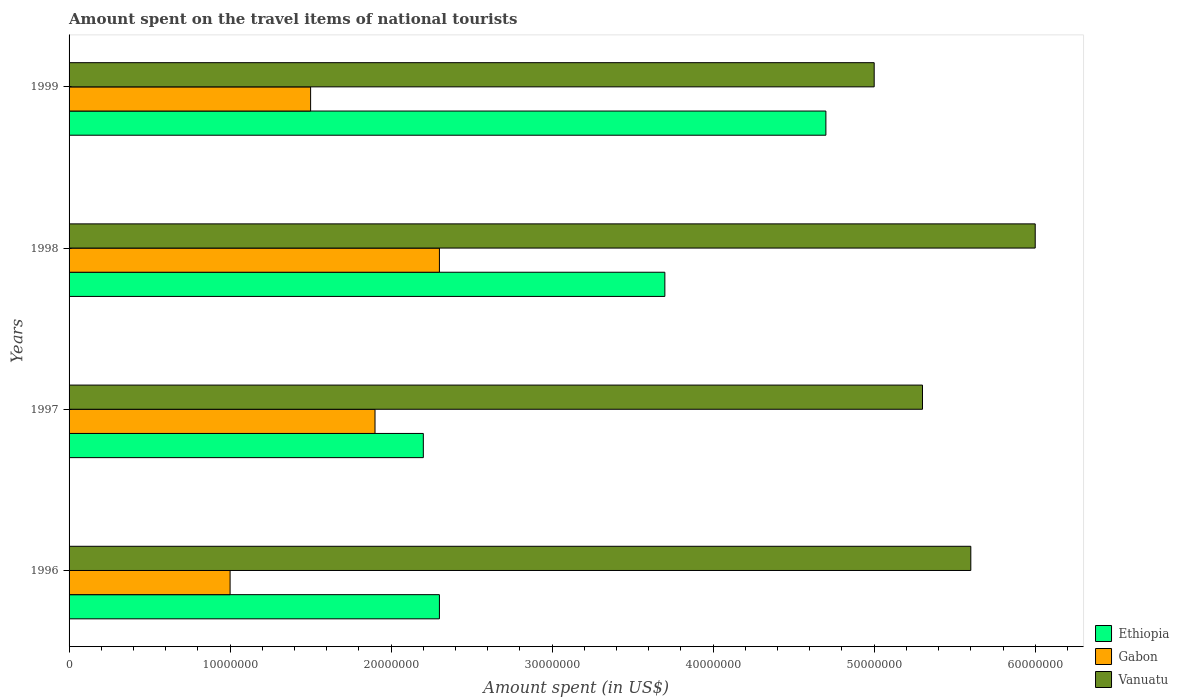Are the number of bars on each tick of the Y-axis equal?
Provide a succinct answer. Yes. How many bars are there on the 4th tick from the top?
Offer a terse response. 3. In how many cases, is the number of bars for a given year not equal to the number of legend labels?
Offer a terse response. 0. What is the amount spent on the travel items of national tourists in Ethiopia in 1998?
Offer a terse response. 3.70e+07. Across all years, what is the maximum amount spent on the travel items of national tourists in Ethiopia?
Provide a succinct answer. 4.70e+07. Across all years, what is the minimum amount spent on the travel items of national tourists in Vanuatu?
Give a very brief answer. 5.00e+07. In which year was the amount spent on the travel items of national tourists in Ethiopia maximum?
Offer a terse response. 1999. In which year was the amount spent on the travel items of national tourists in Ethiopia minimum?
Provide a short and direct response. 1997. What is the total amount spent on the travel items of national tourists in Gabon in the graph?
Offer a very short reply. 6.70e+07. What is the difference between the amount spent on the travel items of national tourists in Ethiopia in 1997 and that in 1998?
Offer a very short reply. -1.50e+07. What is the difference between the amount spent on the travel items of national tourists in Ethiopia in 1996 and the amount spent on the travel items of national tourists in Gabon in 1997?
Provide a short and direct response. 4.00e+06. What is the average amount spent on the travel items of national tourists in Gabon per year?
Keep it short and to the point. 1.68e+07. In the year 1996, what is the difference between the amount spent on the travel items of national tourists in Vanuatu and amount spent on the travel items of national tourists in Gabon?
Ensure brevity in your answer.  4.60e+07. In how many years, is the amount spent on the travel items of national tourists in Ethiopia greater than 24000000 US$?
Provide a short and direct response. 2. What is the ratio of the amount spent on the travel items of national tourists in Ethiopia in 1996 to that in 1998?
Provide a short and direct response. 0.62. What is the difference between the highest and the second highest amount spent on the travel items of national tourists in Ethiopia?
Provide a short and direct response. 1.00e+07. What is the difference between the highest and the lowest amount spent on the travel items of national tourists in Ethiopia?
Make the answer very short. 2.50e+07. In how many years, is the amount spent on the travel items of national tourists in Vanuatu greater than the average amount spent on the travel items of national tourists in Vanuatu taken over all years?
Your answer should be very brief. 2. What does the 1st bar from the top in 1997 represents?
Provide a succinct answer. Vanuatu. What does the 1st bar from the bottom in 1999 represents?
Keep it short and to the point. Ethiopia. Is it the case that in every year, the sum of the amount spent on the travel items of national tourists in Vanuatu and amount spent on the travel items of national tourists in Ethiopia is greater than the amount spent on the travel items of national tourists in Gabon?
Provide a succinct answer. Yes. Are all the bars in the graph horizontal?
Provide a succinct answer. Yes. Does the graph contain any zero values?
Your response must be concise. No. Where does the legend appear in the graph?
Provide a short and direct response. Bottom right. How many legend labels are there?
Your response must be concise. 3. What is the title of the graph?
Offer a very short reply. Amount spent on the travel items of national tourists. Does "Northern Mariana Islands" appear as one of the legend labels in the graph?
Give a very brief answer. No. What is the label or title of the X-axis?
Your response must be concise. Amount spent (in US$). What is the Amount spent (in US$) in Ethiopia in 1996?
Offer a very short reply. 2.30e+07. What is the Amount spent (in US$) of Gabon in 1996?
Provide a short and direct response. 1.00e+07. What is the Amount spent (in US$) of Vanuatu in 1996?
Offer a terse response. 5.60e+07. What is the Amount spent (in US$) in Ethiopia in 1997?
Offer a very short reply. 2.20e+07. What is the Amount spent (in US$) in Gabon in 1997?
Ensure brevity in your answer.  1.90e+07. What is the Amount spent (in US$) in Vanuatu in 1997?
Your answer should be very brief. 5.30e+07. What is the Amount spent (in US$) in Ethiopia in 1998?
Offer a terse response. 3.70e+07. What is the Amount spent (in US$) in Gabon in 1998?
Give a very brief answer. 2.30e+07. What is the Amount spent (in US$) in Vanuatu in 1998?
Keep it short and to the point. 6.00e+07. What is the Amount spent (in US$) of Ethiopia in 1999?
Give a very brief answer. 4.70e+07. What is the Amount spent (in US$) of Gabon in 1999?
Provide a short and direct response. 1.50e+07. What is the Amount spent (in US$) of Vanuatu in 1999?
Your answer should be very brief. 5.00e+07. Across all years, what is the maximum Amount spent (in US$) of Ethiopia?
Ensure brevity in your answer.  4.70e+07. Across all years, what is the maximum Amount spent (in US$) in Gabon?
Give a very brief answer. 2.30e+07. Across all years, what is the maximum Amount spent (in US$) of Vanuatu?
Keep it short and to the point. 6.00e+07. Across all years, what is the minimum Amount spent (in US$) of Ethiopia?
Provide a short and direct response. 2.20e+07. Across all years, what is the minimum Amount spent (in US$) of Gabon?
Offer a very short reply. 1.00e+07. What is the total Amount spent (in US$) of Ethiopia in the graph?
Make the answer very short. 1.29e+08. What is the total Amount spent (in US$) in Gabon in the graph?
Your response must be concise. 6.70e+07. What is the total Amount spent (in US$) in Vanuatu in the graph?
Ensure brevity in your answer.  2.19e+08. What is the difference between the Amount spent (in US$) of Gabon in 1996 and that in 1997?
Offer a very short reply. -9.00e+06. What is the difference between the Amount spent (in US$) of Ethiopia in 1996 and that in 1998?
Your response must be concise. -1.40e+07. What is the difference between the Amount spent (in US$) of Gabon in 1996 and that in 1998?
Your answer should be compact. -1.30e+07. What is the difference between the Amount spent (in US$) in Vanuatu in 1996 and that in 1998?
Offer a very short reply. -4.00e+06. What is the difference between the Amount spent (in US$) of Ethiopia in 1996 and that in 1999?
Offer a terse response. -2.40e+07. What is the difference between the Amount spent (in US$) of Gabon in 1996 and that in 1999?
Keep it short and to the point. -5.00e+06. What is the difference between the Amount spent (in US$) of Vanuatu in 1996 and that in 1999?
Offer a very short reply. 6.00e+06. What is the difference between the Amount spent (in US$) in Ethiopia in 1997 and that in 1998?
Your answer should be compact. -1.50e+07. What is the difference between the Amount spent (in US$) of Vanuatu in 1997 and that in 1998?
Offer a very short reply. -7.00e+06. What is the difference between the Amount spent (in US$) in Ethiopia in 1997 and that in 1999?
Offer a very short reply. -2.50e+07. What is the difference between the Amount spent (in US$) in Vanuatu in 1997 and that in 1999?
Your response must be concise. 3.00e+06. What is the difference between the Amount spent (in US$) in Ethiopia in 1998 and that in 1999?
Your answer should be compact. -1.00e+07. What is the difference between the Amount spent (in US$) in Gabon in 1998 and that in 1999?
Ensure brevity in your answer.  8.00e+06. What is the difference between the Amount spent (in US$) of Ethiopia in 1996 and the Amount spent (in US$) of Gabon in 1997?
Offer a very short reply. 4.00e+06. What is the difference between the Amount spent (in US$) in Ethiopia in 1996 and the Amount spent (in US$) in Vanuatu in 1997?
Offer a very short reply. -3.00e+07. What is the difference between the Amount spent (in US$) in Gabon in 1996 and the Amount spent (in US$) in Vanuatu in 1997?
Keep it short and to the point. -4.30e+07. What is the difference between the Amount spent (in US$) in Ethiopia in 1996 and the Amount spent (in US$) in Vanuatu in 1998?
Give a very brief answer. -3.70e+07. What is the difference between the Amount spent (in US$) in Gabon in 1996 and the Amount spent (in US$) in Vanuatu in 1998?
Keep it short and to the point. -5.00e+07. What is the difference between the Amount spent (in US$) of Ethiopia in 1996 and the Amount spent (in US$) of Gabon in 1999?
Provide a short and direct response. 8.00e+06. What is the difference between the Amount spent (in US$) of Ethiopia in 1996 and the Amount spent (in US$) of Vanuatu in 1999?
Make the answer very short. -2.70e+07. What is the difference between the Amount spent (in US$) of Gabon in 1996 and the Amount spent (in US$) of Vanuatu in 1999?
Your answer should be compact. -4.00e+07. What is the difference between the Amount spent (in US$) in Ethiopia in 1997 and the Amount spent (in US$) in Gabon in 1998?
Offer a very short reply. -1.00e+06. What is the difference between the Amount spent (in US$) in Ethiopia in 1997 and the Amount spent (in US$) in Vanuatu in 1998?
Your answer should be very brief. -3.80e+07. What is the difference between the Amount spent (in US$) in Gabon in 1997 and the Amount spent (in US$) in Vanuatu in 1998?
Keep it short and to the point. -4.10e+07. What is the difference between the Amount spent (in US$) of Ethiopia in 1997 and the Amount spent (in US$) of Vanuatu in 1999?
Provide a short and direct response. -2.80e+07. What is the difference between the Amount spent (in US$) of Gabon in 1997 and the Amount spent (in US$) of Vanuatu in 1999?
Offer a terse response. -3.10e+07. What is the difference between the Amount spent (in US$) in Ethiopia in 1998 and the Amount spent (in US$) in Gabon in 1999?
Offer a very short reply. 2.20e+07. What is the difference between the Amount spent (in US$) in Ethiopia in 1998 and the Amount spent (in US$) in Vanuatu in 1999?
Offer a terse response. -1.30e+07. What is the difference between the Amount spent (in US$) in Gabon in 1998 and the Amount spent (in US$) in Vanuatu in 1999?
Your response must be concise. -2.70e+07. What is the average Amount spent (in US$) in Ethiopia per year?
Offer a terse response. 3.22e+07. What is the average Amount spent (in US$) in Gabon per year?
Your answer should be very brief. 1.68e+07. What is the average Amount spent (in US$) in Vanuatu per year?
Keep it short and to the point. 5.48e+07. In the year 1996, what is the difference between the Amount spent (in US$) in Ethiopia and Amount spent (in US$) in Gabon?
Keep it short and to the point. 1.30e+07. In the year 1996, what is the difference between the Amount spent (in US$) of Ethiopia and Amount spent (in US$) of Vanuatu?
Offer a terse response. -3.30e+07. In the year 1996, what is the difference between the Amount spent (in US$) of Gabon and Amount spent (in US$) of Vanuatu?
Give a very brief answer. -4.60e+07. In the year 1997, what is the difference between the Amount spent (in US$) in Ethiopia and Amount spent (in US$) in Gabon?
Your answer should be compact. 3.00e+06. In the year 1997, what is the difference between the Amount spent (in US$) in Ethiopia and Amount spent (in US$) in Vanuatu?
Offer a terse response. -3.10e+07. In the year 1997, what is the difference between the Amount spent (in US$) in Gabon and Amount spent (in US$) in Vanuatu?
Provide a short and direct response. -3.40e+07. In the year 1998, what is the difference between the Amount spent (in US$) in Ethiopia and Amount spent (in US$) in Gabon?
Provide a succinct answer. 1.40e+07. In the year 1998, what is the difference between the Amount spent (in US$) of Ethiopia and Amount spent (in US$) of Vanuatu?
Your answer should be compact. -2.30e+07. In the year 1998, what is the difference between the Amount spent (in US$) in Gabon and Amount spent (in US$) in Vanuatu?
Offer a very short reply. -3.70e+07. In the year 1999, what is the difference between the Amount spent (in US$) of Ethiopia and Amount spent (in US$) of Gabon?
Provide a short and direct response. 3.20e+07. In the year 1999, what is the difference between the Amount spent (in US$) of Gabon and Amount spent (in US$) of Vanuatu?
Your response must be concise. -3.50e+07. What is the ratio of the Amount spent (in US$) in Ethiopia in 1996 to that in 1997?
Provide a succinct answer. 1.05. What is the ratio of the Amount spent (in US$) of Gabon in 1996 to that in 1997?
Your answer should be very brief. 0.53. What is the ratio of the Amount spent (in US$) in Vanuatu in 1996 to that in 1997?
Offer a very short reply. 1.06. What is the ratio of the Amount spent (in US$) in Ethiopia in 1996 to that in 1998?
Ensure brevity in your answer.  0.62. What is the ratio of the Amount spent (in US$) in Gabon in 1996 to that in 1998?
Ensure brevity in your answer.  0.43. What is the ratio of the Amount spent (in US$) in Vanuatu in 1996 to that in 1998?
Keep it short and to the point. 0.93. What is the ratio of the Amount spent (in US$) of Ethiopia in 1996 to that in 1999?
Provide a succinct answer. 0.49. What is the ratio of the Amount spent (in US$) of Gabon in 1996 to that in 1999?
Your answer should be compact. 0.67. What is the ratio of the Amount spent (in US$) of Vanuatu in 1996 to that in 1999?
Your response must be concise. 1.12. What is the ratio of the Amount spent (in US$) in Ethiopia in 1997 to that in 1998?
Offer a very short reply. 0.59. What is the ratio of the Amount spent (in US$) in Gabon in 1997 to that in 1998?
Offer a very short reply. 0.83. What is the ratio of the Amount spent (in US$) in Vanuatu in 1997 to that in 1998?
Your response must be concise. 0.88. What is the ratio of the Amount spent (in US$) of Ethiopia in 1997 to that in 1999?
Make the answer very short. 0.47. What is the ratio of the Amount spent (in US$) in Gabon in 1997 to that in 1999?
Offer a terse response. 1.27. What is the ratio of the Amount spent (in US$) of Vanuatu in 1997 to that in 1999?
Give a very brief answer. 1.06. What is the ratio of the Amount spent (in US$) in Ethiopia in 1998 to that in 1999?
Offer a terse response. 0.79. What is the ratio of the Amount spent (in US$) in Gabon in 1998 to that in 1999?
Offer a very short reply. 1.53. What is the difference between the highest and the second highest Amount spent (in US$) in Ethiopia?
Make the answer very short. 1.00e+07. What is the difference between the highest and the second highest Amount spent (in US$) in Vanuatu?
Offer a terse response. 4.00e+06. What is the difference between the highest and the lowest Amount spent (in US$) of Ethiopia?
Ensure brevity in your answer.  2.50e+07. What is the difference between the highest and the lowest Amount spent (in US$) of Gabon?
Offer a terse response. 1.30e+07. What is the difference between the highest and the lowest Amount spent (in US$) of Vanuatu?
Provide a succinct answer. 1.00e+07. 